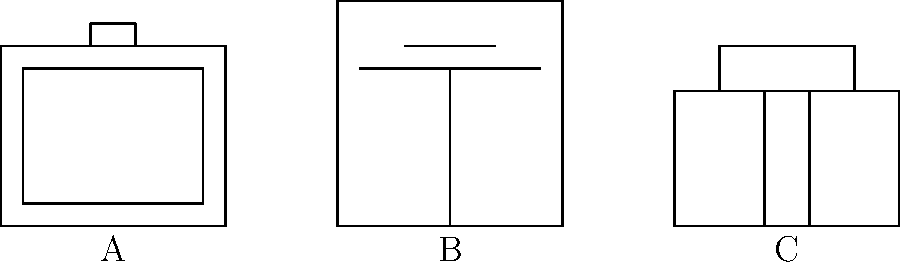Identify the neonatal equipment represented by diagram B in the schematic above. To identify the neonatal equipment represented by diagram B, let's analyze the key features of each diagram:

1. Diagram A:
   - Rectangular shape with a smaller rectangle inside
   - Opening at the top
   - This represents an incubator, used to maintain a controlled environment for newborns

2. Diagram B (the one we need to identify):
   - Rectangular shape
   - Vertical line in the middle
   - Horizontal lines near the top
   - This represents a ventilator, used to assist or replace spontaneous breathing

3. Diagram C:
   - Rectangular shape with a smaller rectangle on top
   - Two vertical lines inside
   - This represents a CPAP (Continuous Positive Airway Pressure) machine, used to maintain positive airway pressure in infants with respiratory difficulties

Based on these characteristics, diagram B clearly represents a ventilator, which is an essential piece of equipment in neonatal intensive care units for providing respiratory support to newborns with breathing difficulties.
Answer: Ventilator 